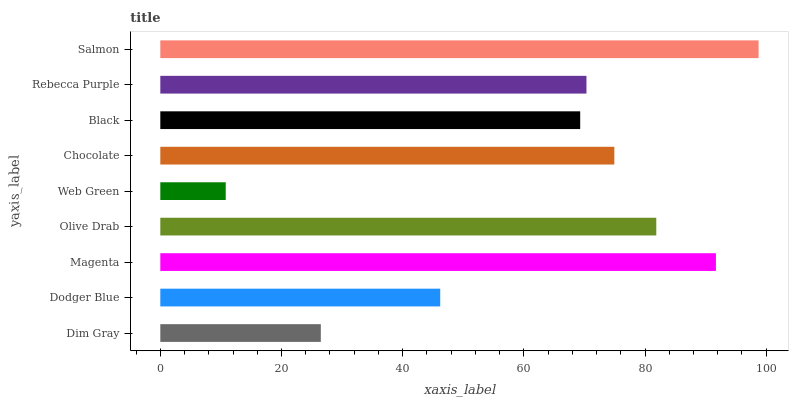Is Web Green the minimum?
Answer yes or no. Yes. Is Salmon the maximum?
Answer yes or no. Yes. Is Dodger Blue the minimum?
Answer yes or no. No. Is Dodger Blue the maximum?
Answer yes or no. No. Is Dodger Blue greater than Dim Gray?
Answer yes or no. Yes. Is Dim Gray less than Dodger Blue?
Answer yes or no. Yes. Is Dim Gray greater than Dodger Blue?
Answer yes or no. No. Is Dodger Blue less than Dim Gray?
Answer yes or no. No. Is Rebecca Purple the high median?
Answer yes or no. Yes. Is Rebecca Purple the low median?
Answer yes or no. Yes. Is Chocolate the high median?
Answer yes or no. No. Is Magenta the low median?
Answer yes or no. No. 